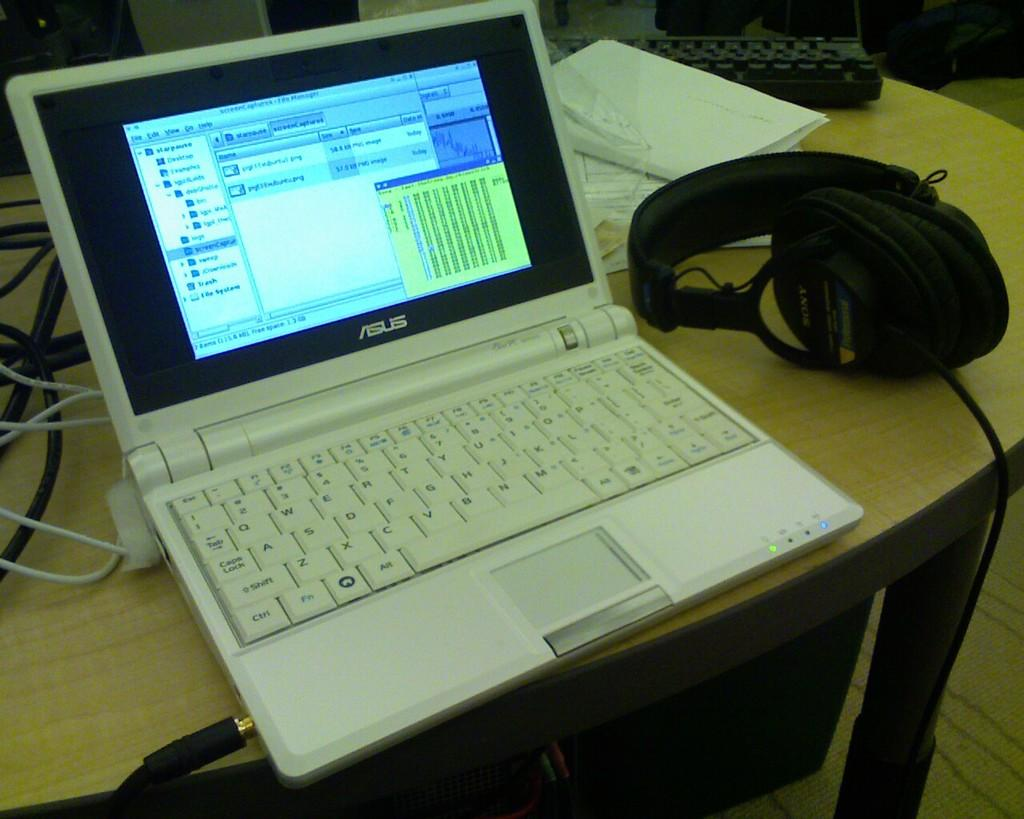<image>
Summarize the visual content of the image. A white Asus laptop sits opened on a table. 